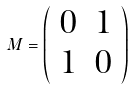<formula> <loc_0><loc_0><loc_500><loc_500>M = \left ( \begin{array} { c c } 0 & 1 \\ 1 & 0 \end{array} \right )</formula> 